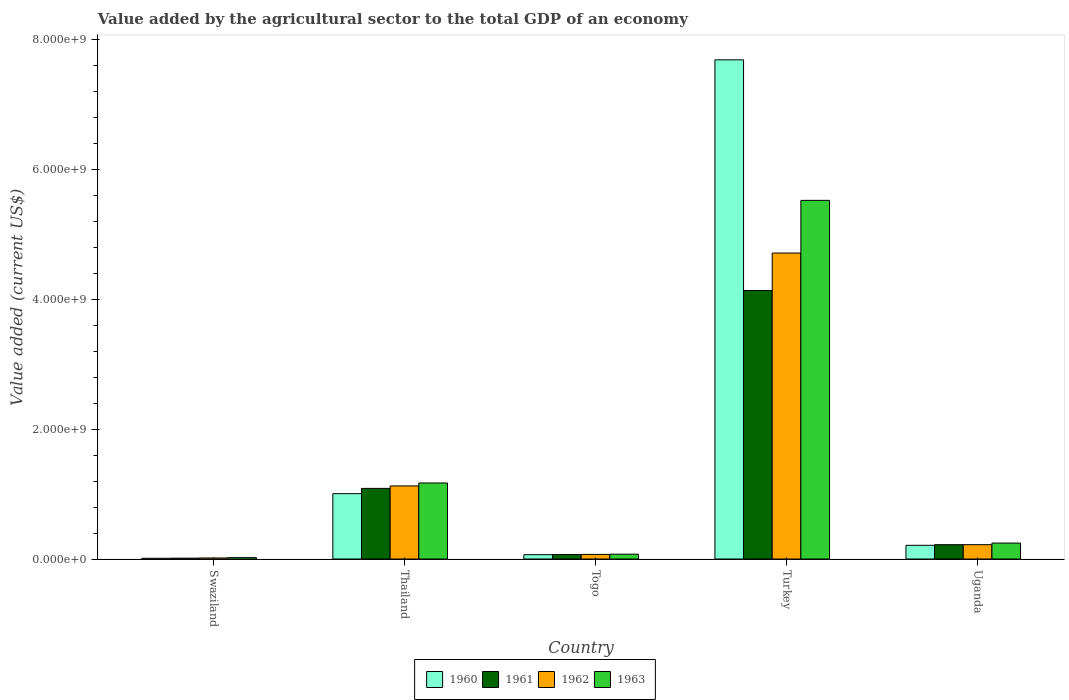How many different coloured bars are there?
Keep it short and to the point. 4. Are the number of bars on each tick of the X-axis equal?
Your answer should be very brief. Yes. How many bars are there on the 5th tick from the right?
Make the answer very short. 4. What is the label of the 1st group of bars from the left?
Your response must be concise. Swaziland. In how many cases, is the number of bars for a given country not equal to the number of legend labels?
Ensure brevity in your answer.  0. What is the value added by the agricultural sector to the total GDP in 1962 in Turkey?
Your answer should be compact. 4.71e+09. Across all countries, what is the maximum value added by the agricultural sector to the total GDP in 1963?
Make the answer very short. 5.52e+09. Across all countries, what is the minimum value added by the agricultural sector to the total GDP in 1963?
Provide a short and direct response. 2.10e+07. In which country was the value added by the agricultural sector to the total GDP in 1962 minimum?
Offer a terse response. Swaziland. What is the total value added by the agricultural sector to the total GDP in 1961 in the graph?
Give a very brief answer. 5.52e+09. What is the difference between the value added by the agricultural sector to the total GDP in 1962 in Turkey and that in Uganda?
Your response must be concise. 4.49e+09. What is the difference between the value added by the agricultural sector to the total GDP in 1962 in Thailand and the value added by the agricultural sector to the total GDP in 1961 in Uganda?
Your answer should be compact. 9.05e+08. What is the average value added by the agricultural sector to the total GDP in 1960 per country?
Provide a succinct answer. 1.80e+09. What is the difference between the value added by the agricultural sector to the total GDP of/in 1960 and value added by the agricultural sector to the total GDP of/in 1963 in Swaziland?
Your answer should be very brief. -9.94e+06. What is the ratio of the value added by the agricultural sector to the total GDP in 1960 in Thailand to that in Uganda?
Keep it short and to the point. 4.77. Is the value added by the agricultural sector to the total GDP in 1963 in Togo less than that in Turkey?
Provide a succinct answer. Yes. What is the difference between the highest and the second highest value added by the agricultural sector to the total GDP in 1962?
Give a very brief answer. 9.04e+08. What is the difference between the highest and the lowest value added by the agricultural sector to the total GDP in 1962?
Provide a short and direct response. 4.70e+09. In how many countries, is the value added by the agricultural sector to the total GDP in 1960 greater than the average value added by the agricultural sector to the total GDP in 1960 taken over all countries?
Ensure brevity in your answer.  1. Is the sum of the value added by the agricultural sector to the total GDP in 1961 in Thailand and Uganda greater than the maximum value added by the agricultural sector to the total GDP in 1960 across all countries?
Make the answer very short. No. What does the 1st bar from the right in Turkey represents?
Make the answer very short. 1963. Does the graph contain any zero values?
Provide a short and direct response. No. How are the legend labels stacked?
Provide a succinct answer. Horizontal. What is the title of the graph?
Your response must be concise. Value added by the agricultural sector to the total GDP of an economy. Does "2008" appear as one of the legend labels in the graph?
Your answer should be very brief. No. What is the label or title of the X-axis?
Your answer should be very brief. Country. What is the label or title of the Y-axis?
Provide a short and direct response. Value added (current US$). What is the Value added (current US$) of 1960 in Swaziland?
Offer a very short reply. 1.11e+07. What is the Value added (current US$) in 1961 in Swaziland?
Provide a succinct answer. 1.30e+07. What is the Value added (current US$) in 1962 in Swaziland?
Provide a succinct answer. 1.60e+07. What is the Value added (current US$) in 1963 in Swaziland?
Your answer should be compact. 2.10e+07. What is the Value added (current US$) in 1960 in Thailand?
Offer a very short reply. 1.01e+09. What is the Value added (current US$) of 1961 in Thailand?
Your response must be concise. 1.09e+09. What is the Value added (current US$) in 1962 in Thailand?
Your answer should be very brief. 1.13e+09. What is the Value added (current US$) of 1963 in Thailand?
Provide a short and direct response. 1.17e+09. What is the Value added (current US$) of 1960 in Togo?
Provide a succinct answer. 6.65e+07. What is the Value added (current US$) of 1961 in Togo?
Your answer should be compact. 6.97e+07. What is the Value added (current US$) of 1962 in Togo?
Make the answer very short. 7.06e+07. What is the Value added (current US$) in 1963 in Togo?
Your response must be concise. 7.43e+07. What is the Value added (current US$) of 1960 in Turkey?
Provide a short and direct response. 7.69e+09. What is the Value added (current US$) of 1961 in Turkey?
Provide a succinct answer. 4.13e+09. What is the Value added (current US$) in 1962 in Turkey?
Your response must be concise. 4.71e+09. What is the Value added (current US$) of 1963 in Turkey?
Keep it short and to the point. 5.52e+09. What is the Value added (current US$) in 1960 in Uganda?
Ensure brevity in your answer.  2.11e+08. What is the Value added (current US$) of 1961 in Uganda?
Your answer should be very brief. 2.20e+08. What is the Value added (current US$) of 1962 in Uganda?
Make the answer very short. 2.21e+08. What is the Value added (current US$) in 1963 in Uganda?
Your response must be concise. 2.45e+08. Across all countries, what is the maximum Value added (current US$) in 1960?
Make the answer very short. 7.69e+09. Across all countries, what is the maximum Value added (current US$) in 1961?
Ensure brevity in your answer.  4.13e+09. Across all countries, what is the maximum Value added (current US$) in 1962?
Give a very brief answer. 4.71e+09. Across all countries, what is the maximum Value added (current US$) of 1963?
Give a very brief answer. 5.52e+09. Across all countries, what is the minimum Value added (current US$) of 1960?
Your answer should be compact. 1.11e+07. Across all countries, what is the minimum Value added (current US$) of 1961?
Ensure brevity in your answer.  1.30e+07. Across all countries, what is the minimum Value added (current US$) in 1962?
Your response must be concise. 1.60e+07. Across all countries, what is the minimum Value added (current US$) in 1963?
Keep it short and to the point. 2.10e+07. What is the total Value added (current US$) in 1960 in the graph?
Give a very brief answer. 8.98e+09. What is the total Value added (current US$) in 1961 in the graph?
Provide a succinct answer. 5.52e+09. What is the total Value added (current US$) of 1962 in the graph?
Your answer should be very brief. 6.14e+09. What is the total Value added (current US$) in 1963 in the graph?
Give a very brief answer. 7.03e+09. What is the difference between the Value added (current US$) of 1960 in Swaziland and that in Thailand?
Give a very brief answer. -9.95e+08. What is the difference between the Value added (current US$) in 1961 in Swaziland and that in Thailand?
Provide a succinct answer. -1.07e+09. What is the difference between the Value added (current US$) in 1962 in Swaziland and that in Thailand?
Ensure brevity in your answer.  -1.11e+09. What is the difference between the Value added (current US$) of 1963 in Swaziland and that in Thailand?
Your answer should be very brief. -1.15e+09. What is the difference between the Value added (current US$) in 1960 in Swaziland and that in Togo?
Make the answer very short. -5.54e+07. What is the difference between the Value added (current US$) in 1961 in Swaziland and that in Togo?
Provide a succinct answer. -5.67e+07. What is the difference between the Value added (current US$) of 1962 in Swaziland and that in Togo?
Provide a short and direct response. -5.46e+07. What is the difference between the Value added (current US$) of 1963 in Swaziland and that in Togo?
Your answer should be very brief. -5.33e+07. What is the difference between the Value added (current US$) in 1960 in Swaziland and that in Turkey?
Ensure brevity in your answer.  -7.67e+09. What is the difference between the Value added (current US$) of 1961 in Swaziland and that in Turkey?
Your answer should be compact. -4.12e+09. What is the difference between the Value added (current US$) in 1962 in Swaziland and that in Turkey?
Offer a terse response. -4.70e+09. What is the difference between the Value added (current US$) in 1963 in Swaziland and that in Turkey?
Your answer should be very brief. -5.50e+09. What is the difference between the Value added (current US$) in 1960 in Swaziland and that in Uganda?
Offer a terse response. -2.00e+08. What is the difference between the Value added (current US$) of 1961 in Swaziland and that in Uganda?
Provide a succinct answer. -2.07e+08. What is the difference between the Value added (current US$) of 1962 in Swaziland and that in Uganda?
Your answer should be very brief. -2.05e+08. What is the difference between the Value added (current US$) of 1963 in Swaziland and that in Uganda?
Ensure brevity in your answer.  -2.24e+08. What is the difference between the Value added (current US$) of 1960 in Thailand and that in Togo?
Offer a terse response. 9.40e+08. What is the difference between the Value added (current US$) of 1961 in Thailand and that in Togo?
Ensure brevity in your answer.  1.02e+09. What is the difference between the Value added (current US$) in 1962 in Thailand and that in Togo?
Your answer should be compact. 1.05e+09. What is the difference between the Value added (current US$) in 1963 in Thailand and that in Togo?
Keep it short and to the point. 1.10e+09. What is the difference between the Value added (current US$) in 1960 in Thailand and that in Turkey?
Your answer should be compact. -6.68e+09. What is the difference between the Value added (current US$) of 1961 in Thailand and that in Turkey?
Offer a terse response. -3.05e+09. What is the difference between the Value added (current US$) of 1962 in Thailand and that in Turkey?
Your response must be concise. -3.59e+09. What is the difference between the Value added (current US$) of 1963 in Thailand and that in Turkey?
Give a very brief answer. -4.35e+09. What is the difference between the Value added (current US$) of 1960 in Thailand and that in Uganda?
Provide a succinct answer. 7.95e+08. What is the difference between the Value added (current US$) of 1961 in Thailand and that in Uganda?
Offer a terse response. 8.67e+08. What is the difference between the Value added (current US$) of 1962 in Thailand and that in Uganda?
Keep it short and to the point. 9.04e+08. What is the difference between the Value added (current US$) of 1963 in Thailand and that in Uganda?
Your answer should be compact. 9.25e+08. What is the difference between the Value added (current US$) of 1960 in Togo and that in Turkey?
Make the answer very short. -7.62e+09. What is the difference between the Value added (current US$) in 1961 in Togo and that in Turkey?
Provide a succinct answer. -4.06e+09. What is the difference between the Value added (current US$) of 1962 in Togo and that in Turkey?
Offer a terse response. -4.64e+09. What is the difference between the Value added (current US$) in 1963 in Togo and that in Turkey?
Make the answer very short. -5.45e+09. What is the difference between the Value added (current US$) in 1960 in Togo and that in Uganda?
Make the answer very short. -1.45e+08. What is the difference between the Value added (current US$) of 1961 in Togo and that in Uganda?
Keep it short and to the point. -1.51e+08. What is the difference between the Value added (current US$) in 1962 in Togo and that in Uganda?
Make the answer very short. -1.50e+08. What is the difference between the Value added (current US$) of 1963 in Togo and that in Uganda?
Your answer should be very brief. -1.71e+08. What is the difference between the Value added (current US$) of 1960 in Turkey and that in Uganda?
Offer a very short reply. 7.47e+09. What is the difference between the Value added (current US$) in 1961 in Turkey and that in Uganda?
Your answer should be very brief. 3.91e+09. What is the difference between the Value added (current US$) of 1962 in Turkey and that in Uganda?
Ensure brevity in your answer.  4.49e+09. What is the difference between the Value added (current US$) in 1963 in Turkey and that in Uganda?
Your response must be concise. 5.28e+09. What is the difference between the Value added (current US$) in 1960 in Swaziland and the Value added (current US$) in 1961 in Thailand?
Your answer should be compact. -1.08e+09. What is the difference between the Value added (current US$) of 1960 in Swaziland and the Value added (current US$) of 1962 in Thailand?
Offer a terse response. -1.11e+09. What is the difference between the Value added (current US$) of 1960 in Swaziland and the Value added (current US$) of 1963 in Thailand?
Keep it short and to the point. -1.16e+09. What is the difference between the Value added (current US$) in 1961 in Swaziland and the Value added (current US$) in 1962 in Thailand?
Ensure brevity in your answer.  -1.11e+09. What is the difference between the Value added (current US$) of 1961 in Swaziland and the Value added (current US$) of 1963 in Thailand?
Your answer should be very brief. -1.16e+09. What is the difference between the Value added (current US$) of 1962 in Swaziland and the Value added (current US$) of 1963 in Thailand?
Provide a succinct answer. -1.15e+09. What is the difference between the Value added (current US$) in 1960 in Swaziland and the Value added (current US$) in 1961 in Togo?
Offer a very short reply. -5.87e+07. What is the difference between the Value added (current US$) in 1960 in Swaziland and the Value added (current US$) in 1962 in Togo?
Make the answer very short. -5.95e+07. What is the difference between the Value added (current US$) in 1960 in Swaziland and the Value added (current US$) in 1963 in Togo?
Make the answer very short. -6.32e+07. What is the difference between the Value added (current US$) of 1961 in Swaziland and the Value added (current US$) of 1962 in Togo?
Provide a short and direct response. -5.76e+07. What is the difference between the Value added (current US$) in 1961 in Swaziland and the Value added (current US$) in 1963 in Togo?
Your answer should be very brief. -6.13e+07. What is the difference between the Value added (current US$) in 1962 in Swaziland and the Value added (current US$) in 1963 in Togo?
Keep it short and to the point. -5.83e+07. What is the difference between the Value added (current US$) of 1960 in Swaziland and the Value added (current US$) of 1961 in Turkey?
Keep it short and to the point. -4.12e+09. What is the difference between the Value added (current US$) in 1960 in Swaziland and the Value added (current US$) in 1962 in Turkey?
Offer a very short reply. -4.70e+09. What is the difference between the Value added (current US$) in 1960 in Swaziland and the Value added (current US$) in 1963 in Turkey?
Make the answer very short. -5.51e+09. What is the difference between the Value added (current US$) in 1961 in Swaziland and the Value added (current US$) in 1962 in Turkey?
Your answer should be very brief. -4.70e+09. What is the difference between the Value added (current US$) in 1961 in Swaziland and the Value added (current US$) in 1963 in Turkey?
Offer a terse response. -5.51e+09. What is the difference between the Value added (current US$) of 1962 in Swaziland and the Value added (current US$) of 1963 in Turkey?
Make the answer very short. -5.51e+09. What is the difference between the Value added (current US$) in 1960 in Swaziland and the Value added (current US$) in 1961 in Uganda?
Ensure brevity in your answer.  -2.09e+08. What is the difference between the Value added (current US$) in 1960 in Swaziland and the Value added (current US$) in 1962 in Uganda?
Provide a succinct answer. -2.10e+08. What is the difference between the Value added (current US$) in 1960 in Swaziland and the Value added (current US$) in 1963 in Uganda?
Your answer should be very brief. -2.34e+08. What is the difference between the Value added (current US$) of 1961 in Swaziland and the Value added (current US$) of 1962 in Uganda?
Provide a short and direct response. -2.08e+08. What is the difference between the Value added (current US$) in 1961 in Swaziland and the Value added (current US$) in 1963 in Uganda?
Offer a very short reply. -2.32e+08. What is the difference between the Value added (current US$) of 1962 in Swaziland and the Value added (current US$) of 1963 in Uganda?
Ensure brevity in your answer.  -2.29e+08. What is the difference between the Value added (current US$) of 1960 in Thailand and the Value added (current US$) of 1961 in Togo?
Make the answer very short. 9.36e+08. What is the difference between the Value added (current US$) of 1960 in Thailand and the Value added (current US$) of 1962 in Togo?
Ensure brevity in your answer.  9.36e+08. What is the difference between the Value added (current US$) in 1960 in Thailand and the Value added (current US$) in 1963 in Togo?
Your answer should be very brief. 9.32e+08. What is the difference between the Value added (current US$) in 1961 in Thailand and the Value added (current US$) in 1962 in Togo?
Your response must be concise. 1.02e+09. What is the difference between the Value added (current US$) in 1961 in Thailand and the Value added (current US$) in 1963 in Togo?
Give a very brief answer. 1.01e+09. What is the difference between the Value added (current US$) of 1962 in Thailand and the Value added (current US$) of 1963 in Togo?
Your response must be concise. 1.05e+09. What is the difference between the Value added (current US$) in 1960 in Thailand and the Value added (current US$) in 1961 in Turkey?
Make the answer very short. -3.13e+09. What is the difference between the Value added (current US$) in 1960 in Thailand and the Value added (current US$) in 1962 in Turkey?
Give a very brief answer. -3.70e+09. What is the difference between the Value added (current US$) of 1960 in Thailand and the Value added (current US$) of 1963 in Turkey?
Keep it short and to the point. -4.52e+09. What is the difference between the Value added (current US$) in 1961 in Thailand and the Value added (current US$) in 1962 in Turkey?
Your answer should be very brief. -3.62e+09. What is the difference between the Value added (current US$) of 1961 in Thailand and the Value added (current US$) of 1963 in Turkey?
Your answer should be very brief. -4.43e+09. What is the difference between the Value added (current US$) in 1962 in Thailand and the Value added (current US$) in 1963 in Turkey?
Ensure brevity in your answer.  -4.40e+09. What is the difference between the Value added (current US$) in 1960 in Thailand and the Value added (current US$) in 1961 in Uganda?
Ensure brevity in your answer.  7.86e+08. What is the difference between the Value added (current US$) in 1960 in Thailand and the Value added (current US$) in 1962 in Uganda?
Offer a terse response. 7.85e+08. What is the difference between the Value added (current US$) in 1960 in Thailand and the Value added (current US$) in 1963 in Uganda?
Provide a short and direct response. 7.61e+08. What is the difference between the Value added (current US$) in 1961 in Thailand and the Value added (current US$) in 1962 in Uganda?
Give a very brief answer. 8.66e+08. What is the difference between the Value added (current US$) of 1961 in Thailand and the Value added (current US$) of 1963 in Uganda?
Give a very brief answer. 8.42e+08. What is the difference between the Value added (current US$) of 1962 in Thailand and the Value added (current US$) of 1963 in Uganda?
Make the answer very short. 8.80e+08. What is the difference between the Value added (current US$) in 1960 in Togo and the Value added (current US$) in 1961 in Turkey?
Offer a terse response. -4.07e+09. What is the difference between the Value added (current US$) of 1960 in Togo and the Value added (current US$) of 1962 in Turkey?
Keep it short and to the point. -4.64e+09. What is the difference between the Value added (current US$) of 1960 in Togo and the Value added (current US$) of 1963 in Turkey?
Your response must be concise. -5.46e+09. What is the difference between the Value added (current US$) in 1961 in Togo and the Value added (current US$) in 1962 in Turkey?
Your response must be concise. -4.64e+09. What is the difference between the Value added (current US$) in 1961 in Togo and the Value added (current US$) in 1963 in Turkey?
Keep it short and to the point. -5.45e+09. What is the difference between the Value added (current US$) in 1962 in Togo and the Value added (current US$) in 1963 in Turkey?
Offer a very short reply. -5.45e+09. What is the difference between the Value added (current US$) in 1960 in Togo and the Value added (current US$) in 1961 in Uganda?
Your answer should be compact. -1.54e+08. What is the difference between the Value added (current US$) of 1960 in Togo and the Value added (current US$) of 1962 in Uganda?
Your answer should be very brief. -1.54e+08. What is the difference between the Value added (current US$) in 1960 in Togo and the Value added (current US$) in 1963 in Uganda?
Give a very brief answer. -1.79e+08. What is the difference between the Value added (current US$) in 1961 in Togo and the Value added (current US$) in 1962 in Uganda?
Provide a succinct answer. -1.51e+08. What is the difference between the Value added (current US$) in 1961 in Togo and the Value added (current US$) in 1963 in Uganda?
Your response must be concise. -1.76e+08. What is the difference between the Value added (current US$) in 1962 in Togo and the Value added (current US$) in 1963 in Uganda?
Give a very brief answer. -1.75e+08. What is the difference between the Value added (current US$) in 1960 in Turkey and the Value added (current US$) in 1961 in Uganda?
Ensure brevity in your answer.  7.47e+09. What is the difference between the Value added (current US$) in 1960 in Turkey and the Value added (current US$) in 1962 in Uganda?
Your response must be concise. 7.47e+09. What is the difference between the Value added (current US$) in 1960 in Turkey and the Value added (current US$) in 1963 in Uganda?
Keep it short and to the point. 7.44e+09. What is the difference between the Value added (current US$) in 1961 in Turkey and the Value added (current US$) in 1962 in Uganda?
Provide a short and direct response. 3.91e+09. What is the difference between the Value added (current US$) of 1961 in Turkey and the Value added (current US$) of 1963 in Uganda?
Give a very brief answer. 3.89e+09. What is the difference between the Value added (current US$) in 1962 in Turkey and the Value added (current US$) in 1963 in Uganda?
Provide a short and direct response. 4.47e+09. What is the average Value added (current US$) of 1960 per country?
Your answer should be compact. 1.80e+09. What is the average Value added (current US$) of 1961 per country?
Your answer should be very brief. 1.10e+09. What is the average Value added (current US$) of 1962 per country?
Give a very brief answer. 1.23e+09. What is the average Value added (current US$) of 1963 per country?
Offer a very short reply. 1.41e+09. What is the difference between the Value added (current US$) of 1960 and Value added (current US$) of 1961 in Swaziland?
Ensure brevity in your answer.  -1.96e+06. What is the difference between the Value added (current US$) in 1960 and Value added (current US$) in 1962 in Swaziland?
Keep it short and to the point. -4.90e+06. What is the difference between the Value added (current US$) in 1960 and Value added (current US$) in 1963 in Swaziland?
Provide a succinct answer. -9.94e+06. What is the difference between the Value added (current US$) of 1961 and Value added (current US$) of 1962 in Swaziland?
Ensure brevity in your answer.  -2.94e+06. What is the difference between the Value added (current US$) in 1961 and Value added (current US$) in 1963 in Swaziland?
Give a very brief answer. -7.98e+06. What is the difference between the Value added (current US$) in 1962 and Value added (current US$) in 1963 in Swaziland?
Make the answer very short. -5.04e+06. What is the difference between the Value added (current US$) in 1960 and Value added (current US$) in 1961 in Thailand?
Provide a succinct answer. -8.12e+07. What is the difference between the Value added (current US$) of 1960 and Value added (current US$) of 1962 in Thailand?
Provide a succinct answer. -1.19e+08. What is the difference between the Value added (current US$) of 1960 and Value added (current US$) of 1963 in Thailand?
Offer a very short reply. -1.65e+08. What is the difference between the Value added (current US$) of 1961 and Value added (current US$) of 1962 in Thailand?
Make the answer very short. -3.78e+07. What is the difference between the Value added (current US$) in 1961 and Value added (current US$) in 1963 in Thailand?
Offer a terse response. -8.33e+07. What is the difference between the Value added (current US$) of 1962 and Value added (current US$) of 1963 in Thailand?
Provide a succinct answer. -4.55e+07. What is the difference between the Value added (current US$) in 1960 and Value added (current US$) in 1961 in Togo?
Provide a short and direct response. -3.24e+06. What is the difference between the Value added (current US$) of 1960 and Value added (current US$) of 1962 in Togo?
Provide a succinct answer. -4.13e+06. What is the difference between the Value added (current US$) of 1960 and Value added (current US$) of 1963 in Togo?
Ensure brevity in your answer.  -7.80e+06. What is the difference between the Value added (current US$) in 1961 and Value added (current US$) in 1962 in Togo?
Provide a short and direct response. -8.86e+05. What is the difference between the Value added (current US$) of 1961 and Value added (current US$) of 1963 in Togo?
Make the answer very short. -4.56e+06. What is the difference between the Value added (current US$) in 1962 and Value added (current US$) in 1963 in Togo?
Your answer should be compact. -3.67e+06. What is the difference between the Value added (current US$) of 1960 and Value added (current US$) of 1961 in Turkey?
Give a very brief answer. 3.55e+09. What is the difference between the Value added (current US$) in 1960 and Value added (current US$) in 1962 in Turkey?
Your answer should be compact. 2.97e+09. What is the difference between the Value added (current US$) of 1960 and Value added (current US$) of 1963 in Turkey?
Ensure brevity in your answer.  2.16e+09. What is the difference between the Value added (current US$) of 1961 and Value added (current US$) of 1962 in Turkey?
Offer a very short reply. -5.78e+08. What is the difference between the Value added (current US$) in 1961 and Value added (current US$) in 1963 in Turkey?
Your response must be concise. -1.39e+09. What is the difference between the Value added (current US$) of 1962 and Value added (current US$) of 1963 in Turkey?
Make the answer very short. -8.11e+08. What is the difference between the Value added (current US$) in 1960 and Value added (current US$) in 1961 in Uganda?
Provide a succinct answer. -9.45e+06. What is the difference between the Value added (current US$) in 1960 and Value added (current US$) in 1962 in Uganda?
Offer a very short reply. -9.86e+06. What is the difference between the Value added (current US$) of 1960 and Value added (current US$) of 1963 in Uganda?
Provide a short and direct response. -3.43e+07. What is the difference between the Value added (current US$) in 1961 and Value added (current US$) in 1962 in Uganda?
Offer a terse response. -4.07e+05. What is the difference between the Value added (current US$) in 1961 and Value added (current US$) in 1963 in Uganda?
Give a very brief answer. -2.48e+07. What is the difference between the Value added (current US$) in 1962 and Value added (current US$) in 1963 in Uganda?
Your answer should be very brief. -2.44e+07. What is the ratio of the Value added (current US$) of 1960 in Swaziland to that in Thailand?
Keep it short and to the point. 0.01. What is the ratio of the Value added (current US$) in 1961 in Swaziland to that in Thailand?
Your answer should be very brief. 0.01. What is the ratio of the Value added (current US$) of 1962 in Swaziland to that in Thailand?
Your answer should be very brief. 0.01. What is the ratio of the Value added (current US$) of 1963 in Swaziland to that in Thailand?
Offer a terse response. 0.02. What is the ratio of the Value added (current US$) in 1960 in Swaziland to that in Togo?
Provide a succinct answer. 0.17. What is the ratio of the Value added (current US$) of 1961 in Swaziland to that in Togo?
Ensure brevity in your answer.  0.19. What is the ratio of the Value added (current US$) of 1962 in Swaziland to that in Togo?
Keep it short and to the point. 0.23. What is the ratio of the Value added (current US$) in 1963 in Swaziland to that in Togo?
Provide a short and direct response. 0.28. What is the ratio of the Value added (current US$) of 1960 in Swaziland to that in Turkey?
Provide a succinct answer. 0. What is the ratio of the Value added (current US$) in 1961 in Swaziland to that in Turkey?
Your answer should be compact. 0. What is the ratio of the Value added (current US$) in 1962 in Swaziland to that in Turkey?
Your answer should be compact. 0. What is the ratio of the Value added (current US$) in 1963 in Swaziland to that in Turkey?
Ensure brevity in your answer.  0. What is the ratio of the Value added (current US$) in 1960 in Swaziland to that in Uganda?
Ensure brevity in your answer.  0.05. What is the ratio of the Value added (current US$) in 1961 in Swaziland to that in Uganda?
Your answer should be very brief. 0.06. What is the ratio of the Value added (current US$) of 1962 in Swaziland to that in Uganda?
Give a very brief answer. 0.07. What is the ratio of the Value added (current US$) of 1963 in Swaziland to that in Uganda?
Your answer should be very brief. 0.09. What is the ratio of the Value added (current US$) in 1960 in Thailand to that in Togo?
Keep it short and to the point. 15.13. What is the ratio of the Value added (current US$) of 1961 in Thailand to that in Togo?
Offer a terse response. 15.6. What is the ratio of the Value added (current US$) in 1962 in Thailand to that in Togo?
Give a very brief answer. 15.93. What is the ratio of the Value added (current US$) of 1963 in Thailand to that in Togo?
Your answer should be very brief. 15.76. What is the ratio of the Value added (current US$) in 1960 in Thailand to that in Turkey?
Provide a succinct answer. 0.13. What is the ratio of the Value added (current US$) of 1961 in Thailand to that in Turkey?
Give a very brief answer. 0.26. What is the ratio of the Value added (current US$) of 1962 in Thailand to that in Turkey?
Your response must be concise. 0.24. What is the ratio of the Value added (current US$) in 1963 in Thailand to that in Turkey?
Offer a terse response. 0.21. What is the ratio of the Value added (current US$) in 1960 in Thailand to that in Uganda?
Your answer should be compact. 4.77. What is the ratio of the Value added (current US$) in 1961 in Thailand to that in Uganda?
Give a very brief answer. 4.93. What is the ratio of the Value added (current US$) in 1962 in Thailand to that in Uganda?
Keep it short and to the point. 5.09. What is the ratio of the Value added (current US$) in 1963 in Thailand to that in Uganda?
Give a very brief answer. 4.77. What is the ratio of the Value added (current US$) of 1960 in Togo to that in Turkey?
Your response must be concise. 0.01. What is the ratio of the Value added (current US$) in 1961 in Togo to that in Turkey?
Your response must be concise. 0.02. What is the ratio of the Value added (current US$) in 1962 in Togo to that in Turkey?
Your answer should be very brief. 0.01. What is the ratio of the Value added (current US$) in 1963 in Togo to that in Turkey?
Ensure brevity in your answer.  0.01. What is the ratio of the Value added (current US$) in 1960 in Togo to that in Uganda?
Offer a very short reply. 0.32. What is the ratio of the Value added (current US$) in 1961 in Togo to that in Uganda?
Make the answer very short. 0.32. What is the ratio of the Value added (current US$) of 1962 in Togo to that in Uganda?
Provide a short and direct response. 0.32. What is the ratio of the Value added (current US$) in 1963 in Togo to that in Uganda?
Your response must be concise. 0.3. What is the ratio of the Value added (current US$) of 1960 in Turkey to that in Uganda?
Your answer should be very brief. 36.42. What is the ratio of the Value added (current US$) in 1961 in Turkey to that in Uganda?
Make the answer very short. 18.75. What is the ratio of the Value added (current US$) in 1962 in Turkey to that in Uganda?
Give a very brief answer. 21.33. What is the ratio of the Value added (current US$) of 1963 in Turkey to that in Uganda?
Offer a very short reply. 22.51. What is the difference between the highest and the second highest Value added (current US$) in 1960?
Your answer should be very brief. 6.68e+09. What is the difference between the highest and the second highest Value added (current US$) in 1961?
Provide a succinct answer. 3.05e+09. What is the difference between the highest and the second highest Value added (current US$) of 1962?
Give a very brief answer. 3.59e+09. What is the difference between the highest and the second highest Value added (current US$) in 1963?
Keep it short and to the point. 4.35e+09. What is the difference between the highest and the lowest Value added (current US$) of 1960?
Offer a very short reply. 7.67e+09. What is the difference between the highest and the lowest Value added (current US$) in 1961?
Make the answer very short. 4.12e+09. What is the difference between the highest and the lowest Value added (current US$) in 1962?
Offer a very short reply. 4.70e+09. What is the difference between the highest and the lowest Value added (current US$) of 1963?
Make the answer very short. 5.50e+09. 